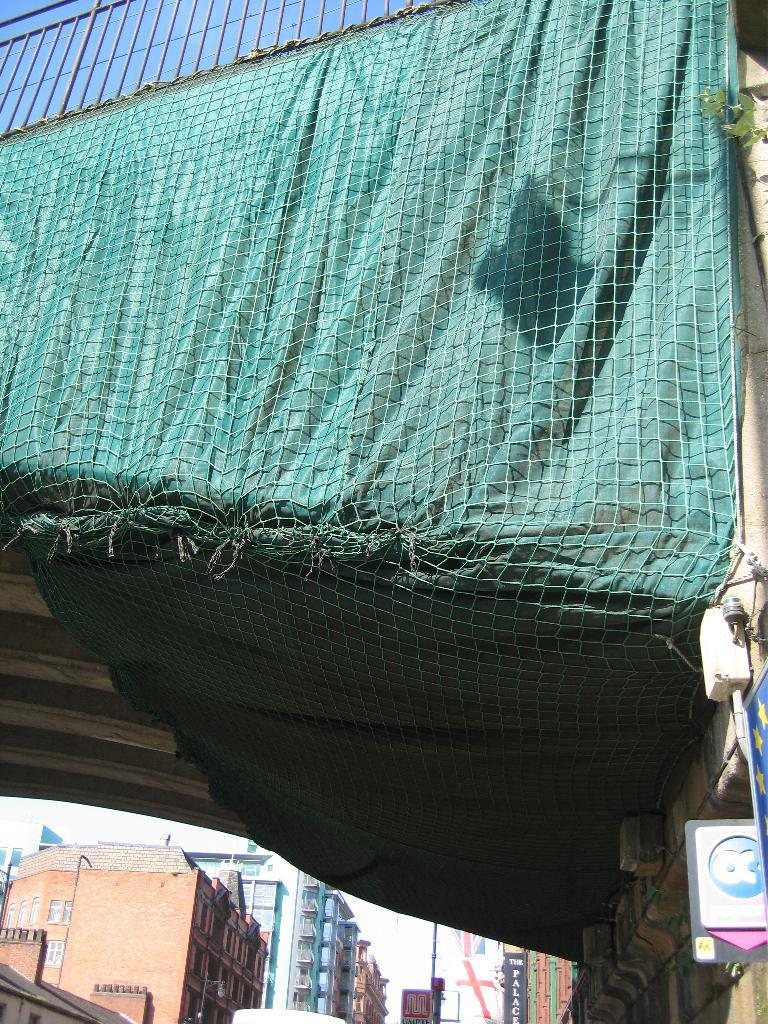What type of structures can be seen in the image? There are buildings in the image. What is present in the image that serves as a barrier or boundary? There is a fencing in the image. What is attached to the fencing in the image? A green cloth is attached to the fencing. What other object can be seen in the image? There is a board in the image. How does the pollution affect the comfort of the daughter in the image? There is no mention of pollution, comfort, or a daughter in the image; the facts provided only discuss buildings, fencing, a green cloth, and a board. 